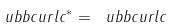Convert formula to latex. <formula><loc_0><loc_0><loc_500><loc_500>\ u b b c u r l c ^ { * } = \ u b b c u r l c</formula> 